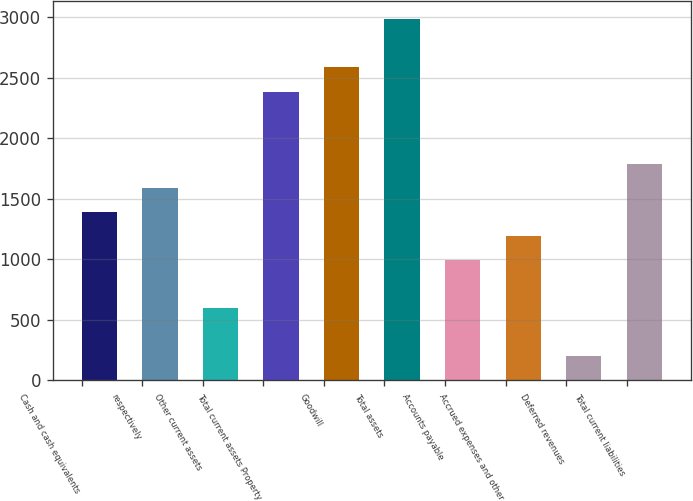<chart> <loc_0><loc_0><loc_500><loc_500><bar_chart><fcel>Cash and cash equivalents<fcel>respectively<fcel>Other current assets<fcel>Total current assets Property<fcel>Goodwill<fcel>Total assets<fcel>Accounts payable<fcel>Accrued expenses and other<fcel>Deferred revenues<fcel>Total current liabilities<nl><fcel>1391.77<fcel>1590.38<fcel>597.33<fcel>2384.82<fcel>2583.43<fcel>2980.65<fcel>994.55<fcel>1193.16<fcel>200.11<fcel>1788.99<nl></chart> 